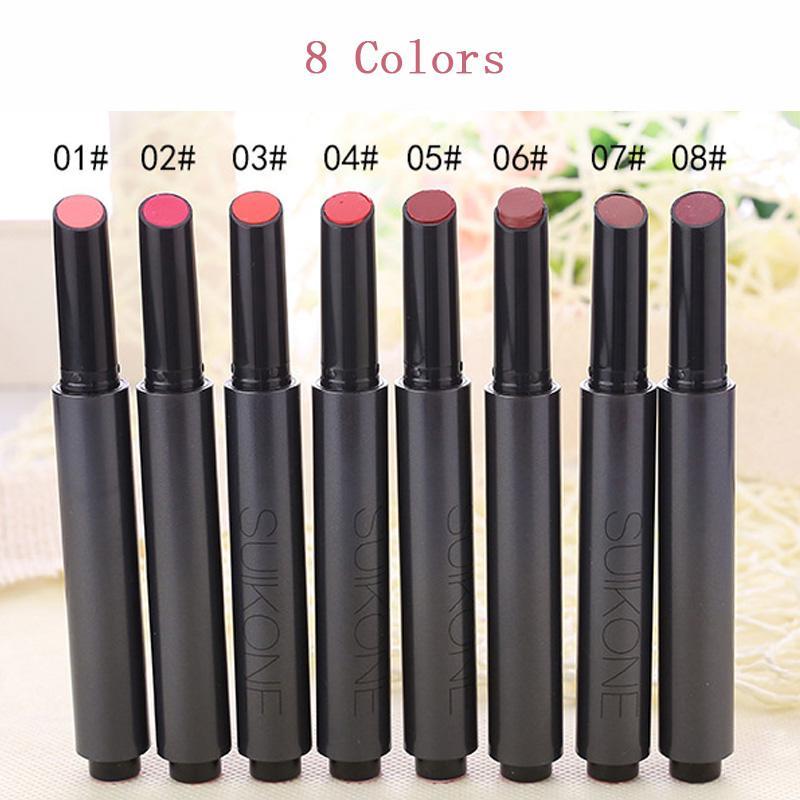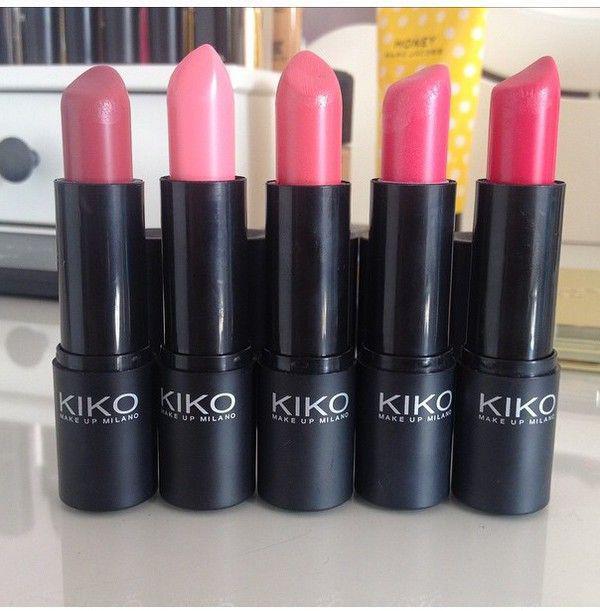The first image is the image on the left, the second image is the image on the right. Assess this claim about the two images: "The right image includes an odd number of lipsticks standing up with their caps off.". Correct or not? Answer yes or no. Yes. 